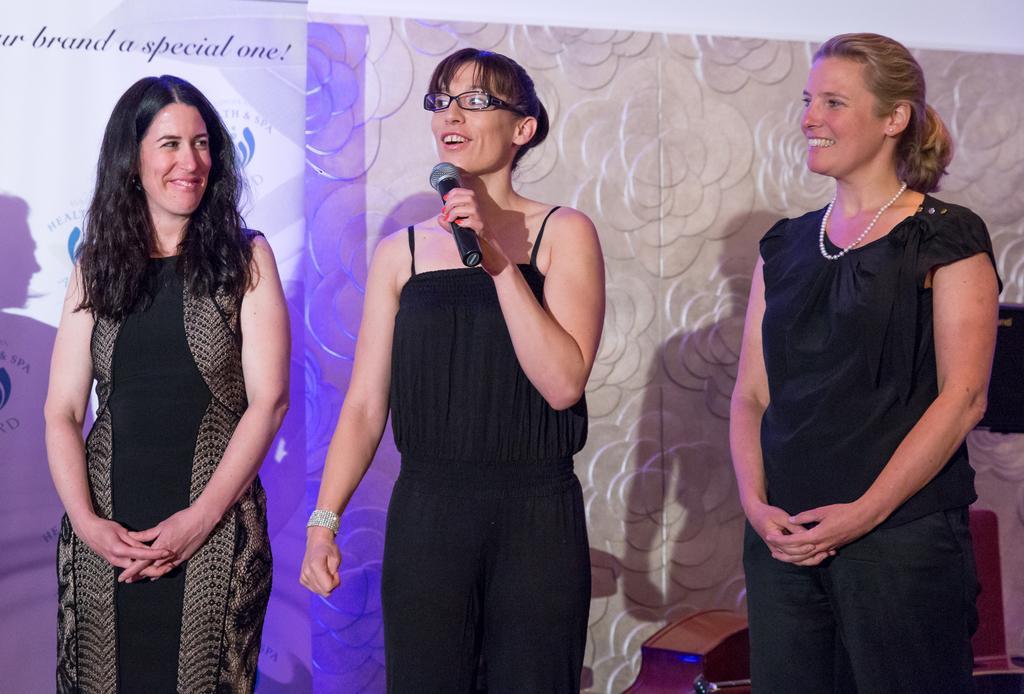In one or two sentences, can you explain what this image depicts? In the image we can see there are three women standing and a woman in the middle is holding a mic in her hand and she is wearing spectacles. Behind there is a banner on the wall. 